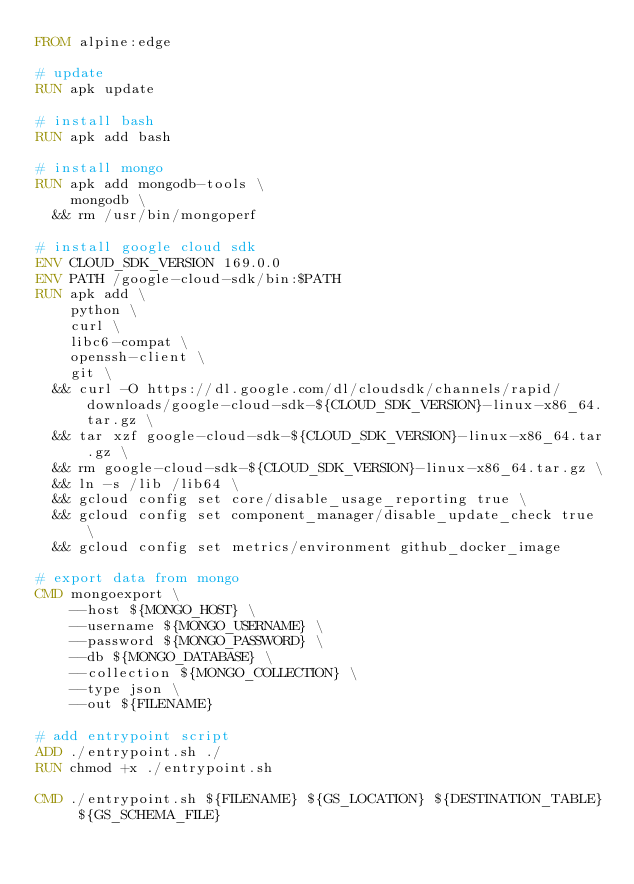Convert code to text. <code><loc_0><loc_0><loc_500><loc_500><_Dockerfile_>FROM alpine:edge

# update
RUN apk update

# install bash
RUN apk add bash

# install mongo
RUN apk add mongodb-tools \
    mongodb \
  && rm /usr/bin/mongoperf

# install google cloud sdk
ENV CLOUD_SDK_VERSION 169.0.0
ENV PATH /google-cloud-sdk/bin:$PATH
RUN apk add \
    python \
    curl \
    libc6-compat \
    openssh-client \
    git \
  && curl -O https://dl.google.com/dl/cloudsdk/channels/rapid/downloads/google-cloud-sdk-${CLOUD_SDK_VERSION}-linux-x86_64.tar.gz \
  && tar xzf google-cloud-sdk-${CLOUD_SDK_VERSION}-linux-x86_64.tar.gz \
  && rm google-cloud-sdk-${CLOUD_SDK_VERSION}-linux-x86_64.tar.gz \
  && ln -s /lib /lib64 \
  && gcloud config set core/disable_usage_reporting true \
  && gcloud config set component_manager/disable_update_check true \
  && gcloud config set metrics/environment github_docker_image

# export data from mongo
CMD mongoexport \
    --host ${MONGO_HOST} \
    --username ${MONGO_USERNAME} \
    --password ${MONGO_PASSWORD} \
    --db ${MONGO_DATABASE} \
    --collection ${MONGO_COLLECTION} \
    --type json \
    --out ${FILENAME}

# add entrypoint script
ADD ./entrypoint.sh ./
RUN chmod +x ./entrypoint.sh

CMD ./entrypoint.sh ${FILENAME} ${GS_LOCATION} ${DESTINATION_TABLE} ${GS_SCHEMA_FILE}
</code> 